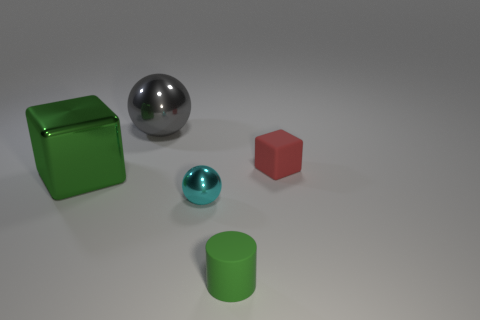There is a block that is the same size as the gray shiny object; what is its material?
Your answer should be compact. Metal. Does the sphere that is behind the red object have the same color as the block to the left of the small green rubber cylinder?
Provide a succinct answer. No. Is there a large yellow object that has the same shape as the small shiny thing?
Offer a terse response. No. There is a object that is the same size as the gray ball; what shape is it?
Make the answer very short. Cube. How many cylinders have the same color as the big block?
Provide a short and direct response. 1. What is the size of the cube that is on the right side of the large green metal block?
Offer a terse response. Small. What number of blue shiny cylinders have the same size as the shiny cube?
Your answer should be compact. 0. There is a cube that is the same material as the green cylinder; what color is it?
Your answer should be very brief. Red. Are there fewer shiny blocks that are in front of the tiny green matte cylinder than small cyan objects?
Keep it short and to the point. Yes. What shape is the cyan object that is the same material as the green cube?
Your answer should be compact. Sphere. 